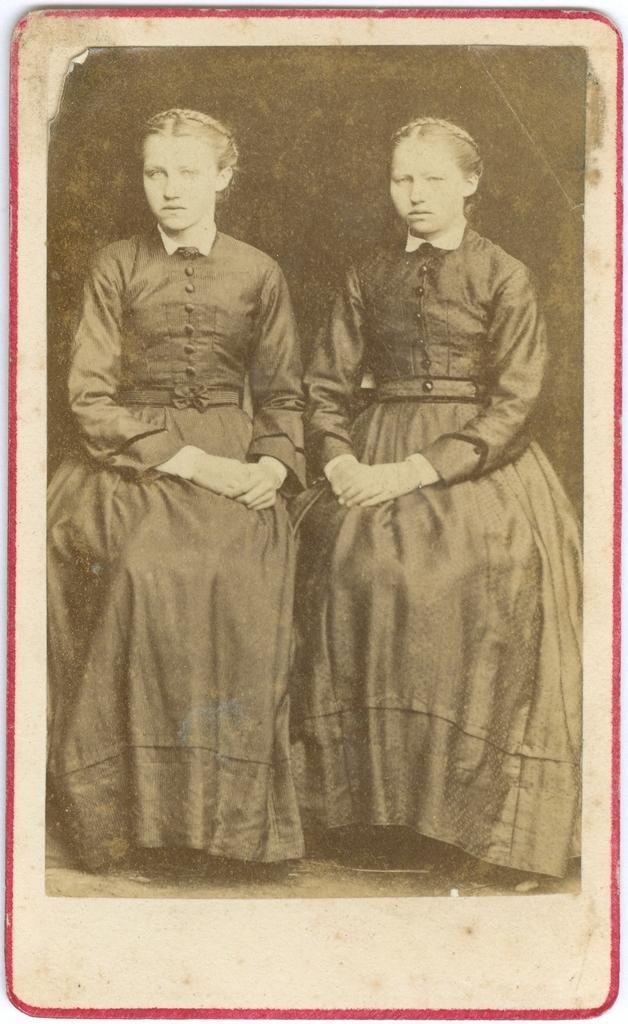In one or two sentences, can you explain what this image depicts? This is an old black and white image. I can see two women sitting. This looks like a red border. 